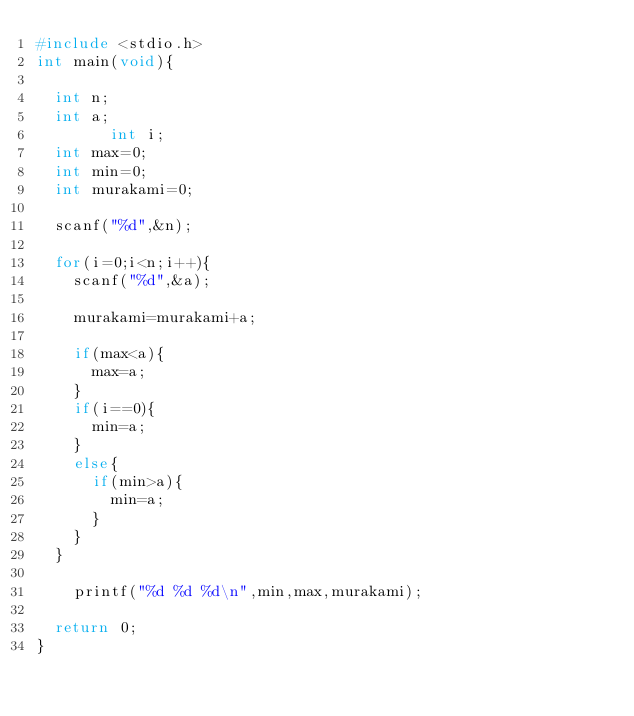<code> <loc_0><loc_0><loc_500><loc_500><_C_>#include <stdio.h>
int main(void){
	
	int n;
	int a;
        int i;
	int max=0;
	int min=0;
	int murakami=0;
	
	scanf("%d",&n);
	
	for(i=0;i<n;i++){
		scanf("%d",&a);
		
		murakami=murakami+a;
		
		if(max<a){
			max=a;
		}
		if(i==0){
			min=a;
		}
		else{
			if(min>a){
				min=a;
			}
		}
	}
		
		printf("%d %d %d\n",min,max,murakami);
	
	return 0;
}</code> 